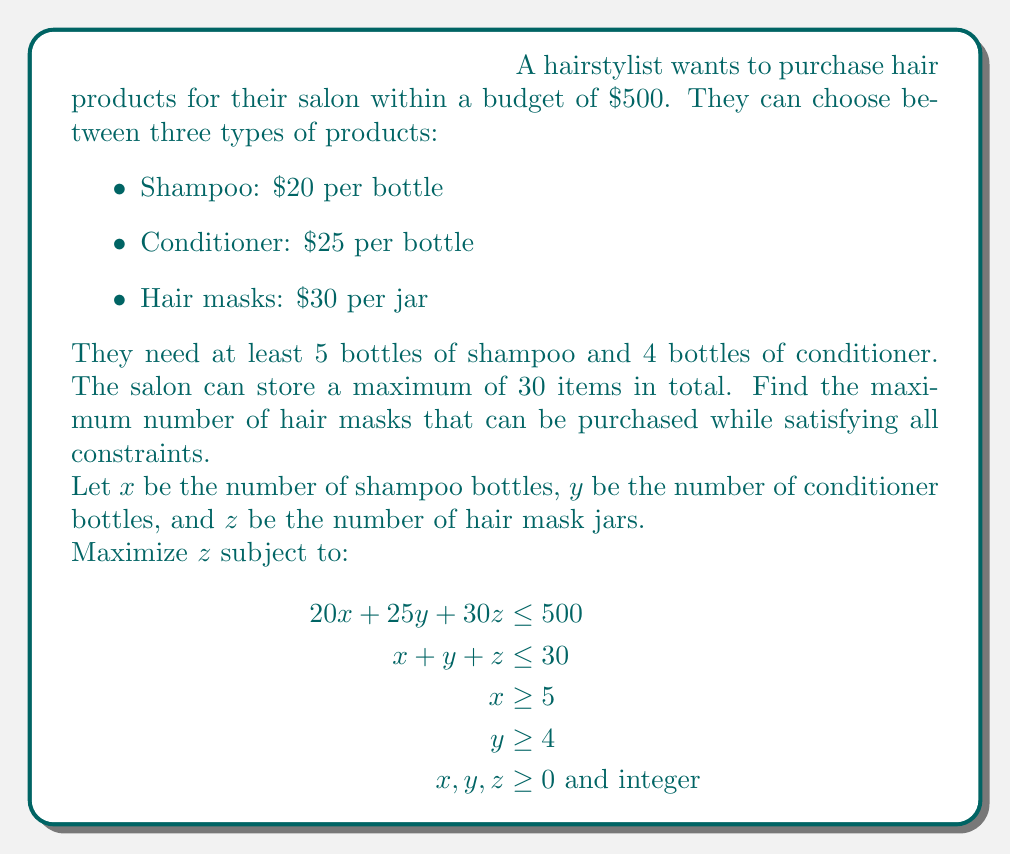Help me with this question. To solve this problem, we'll follow these steps:

1) First, we know that $x \geq 5$ and $y \geq 4$. Let's start by setting $x = 5$ and $y = 4$ to maximize the budget available for hair masks.

2) With $x = 5$ and $y = 4$, we've used 9 out of the 30 available storage spaces. This means we have 21 spaces left for hair masks: $z \leq 21$.

3) Now, let's look at the budget constraint:
   $20(5) + 25(4) + 30z \leq 500$
   $100 + 100 + 30z \leq 500$
   $30z \leq 300$
   $z \leq 10$

4) The budget constraint is more restrictive than the storage constraint, so the maximum number of hair masks is 10.

5) Let's verify that this solution satisfies all constraints:
   - Budget: $20(5) + 25(4) + 30(10) = 500$ (exactly at the budget limit)
   - Storage: $5 + 4 + 10 = 19$ (less than the 30 item limit)
   - Minimum shampoo and conditioner requirements are met

Therefore, the maximum number of hair masks that can be purchased is 10.
Answer: 10 hair masks 